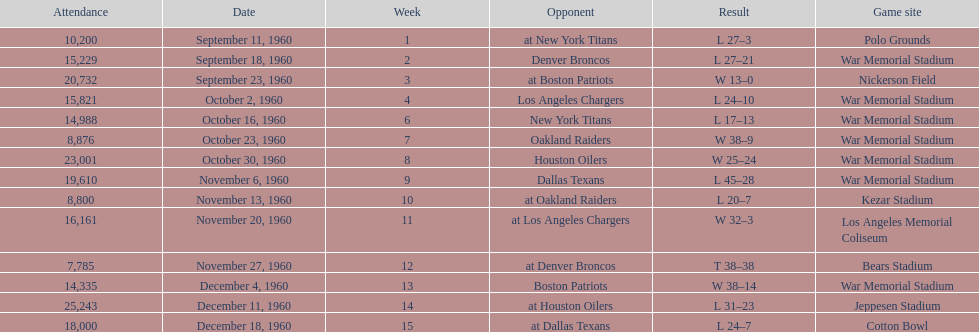Which date had the highest attendance? December 11, 1960. 